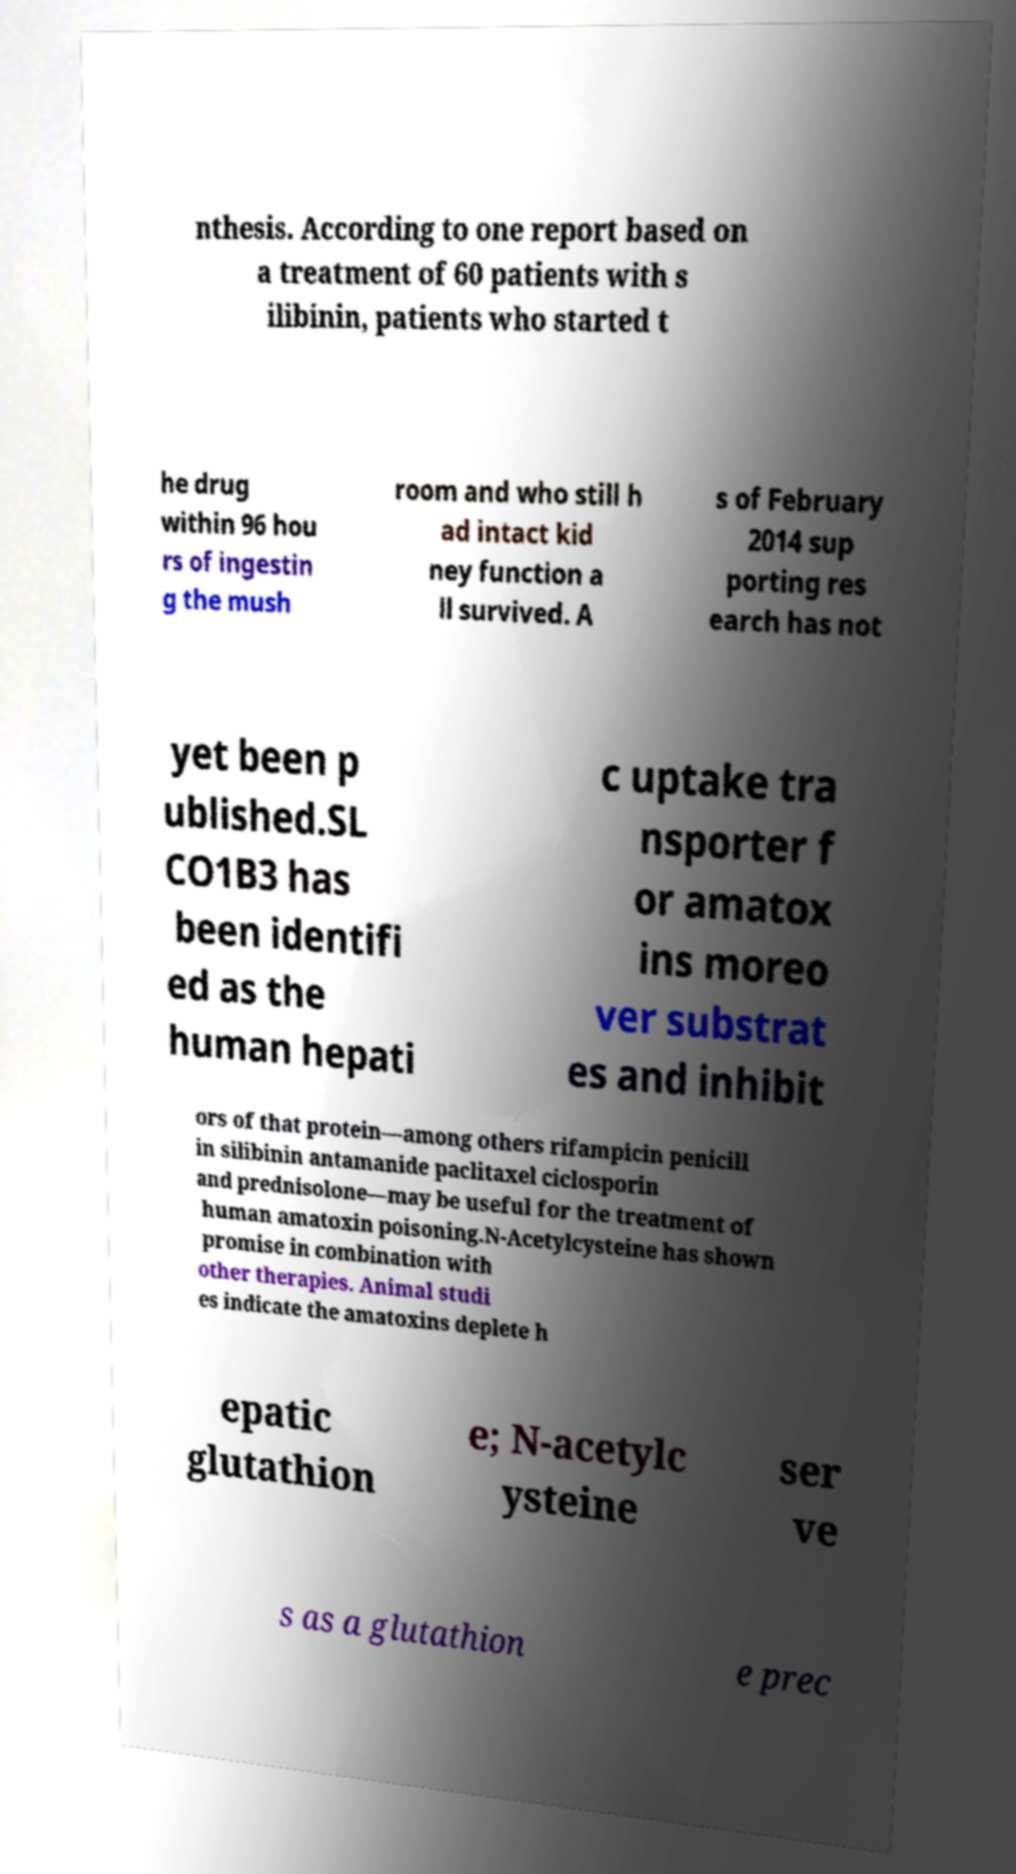Could you assist in decoding the text presented in this image and type it out clearly? nthesis. According to one report based on a treatment of 60 patients with s ilibinin, patients who started t he drug within 96 hou rs of ingestin g the mush room and who still h ad intact kid ney function a ll survived. A s of February 2014 sup porting res earch has not yet been p ublished.SL CO1B3 has been identifi ed as the human hepati c uptake tra nsporter f or amatox ins moreo ver substrat es and inhibit ors of that protein—among others rifampicin penicill in silibinin antamanide paclitaxel ciclosporin and prednisolone—may be useful for the treatment of human amatoxin poisoning.N-Acetylcysteine has shown promise in combination with other therapies. Animal studi es indicate the amatoxins deplete h epatic glutathion e; N-acetylc ysteine ser ve s as a glutathion e prec 